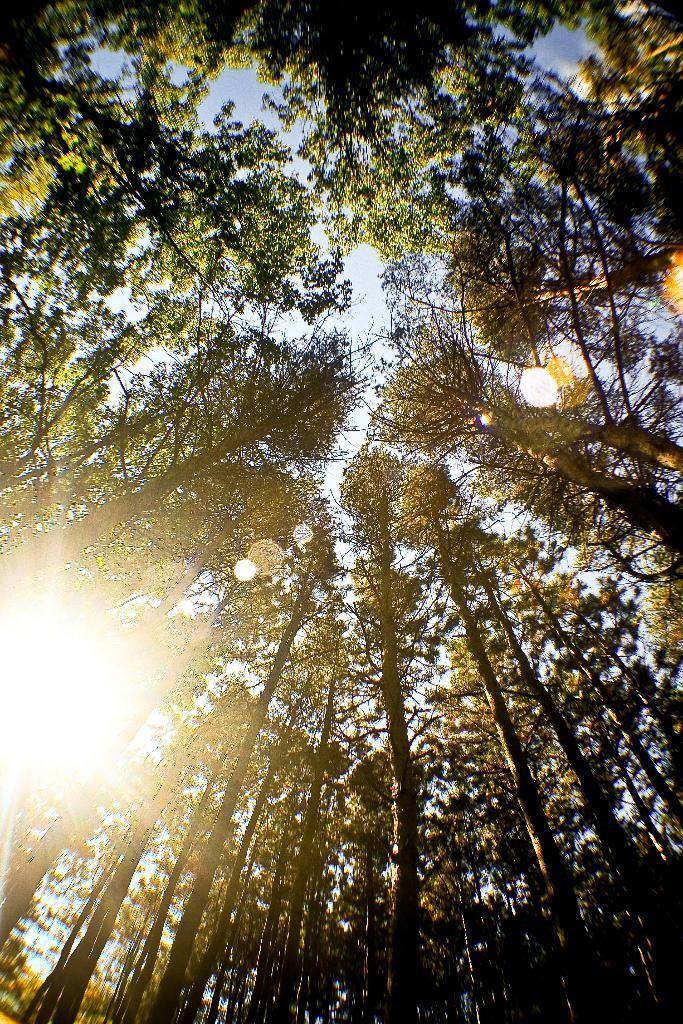What type of vegetation can be seen in the image? There are trees in the image. What is visible in the background of the image? The sky is visible in the background of the image. Can you describe the lighting conditions in the image? Sunlight is present in the image. What statement does the uncle make about the rake in the image? There is no uncle or rake present in the image, so it is not possible to answer that question. 